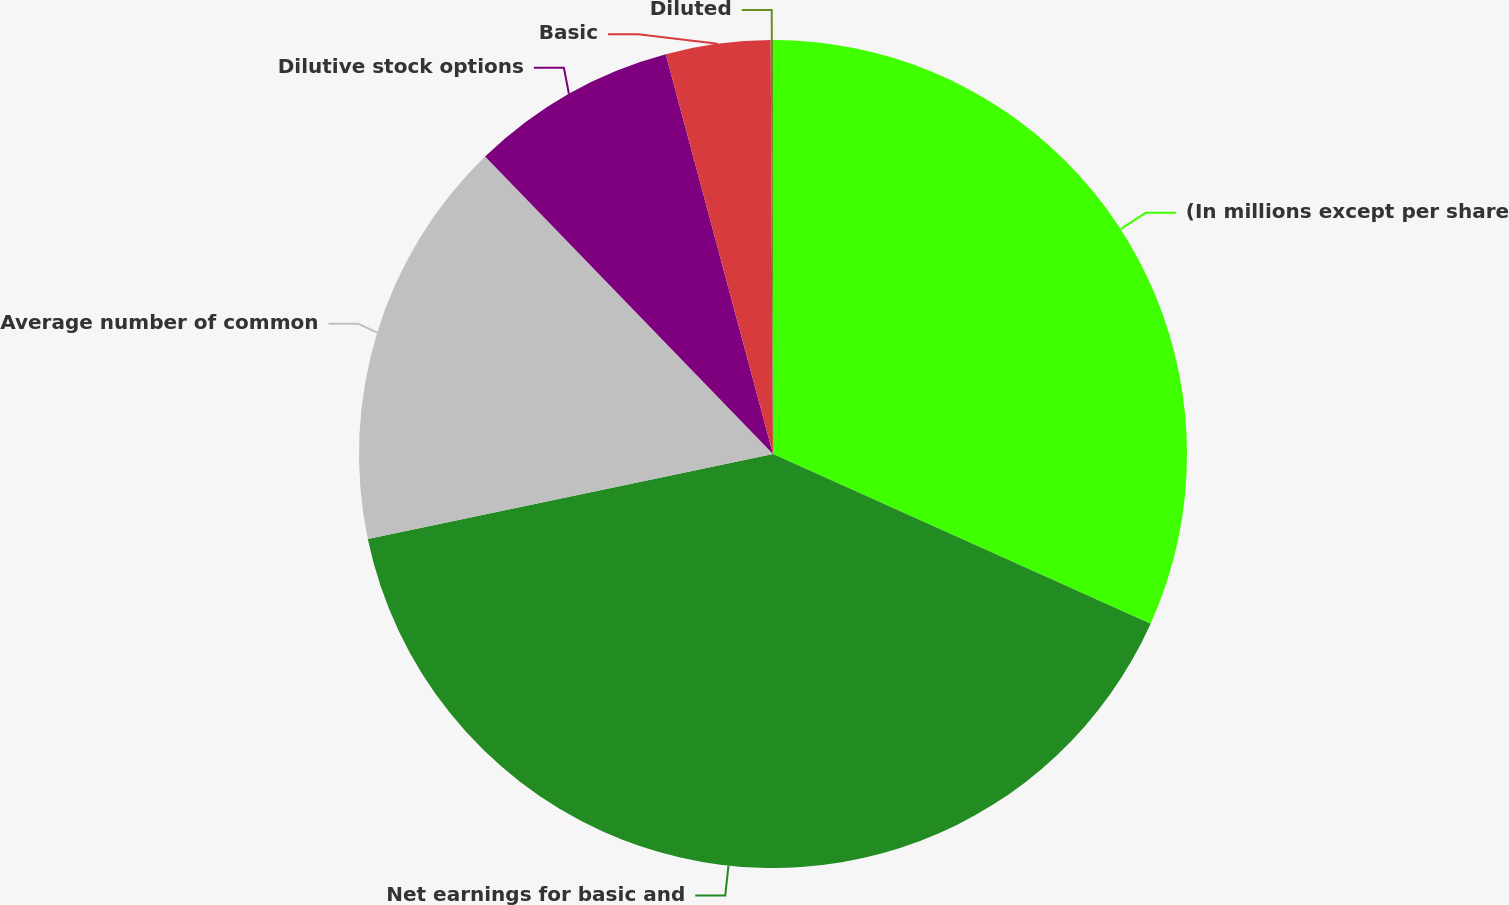Convert chart. <chart><loc_0><loc_0><loc_500><loc_500><pie_chart><fcel>(In millions except per share<fcel>Net earnings for basic and<fcel>Average number of common<fcel>Dilutive stock options<fcel>Basic<fcel>Diluted<nl><fcel>31.72%<fcel>39.99%<fcel>16.05%<fcel>8.07%<fcel>4.08%<fcel>0.09%<nl></chart> 